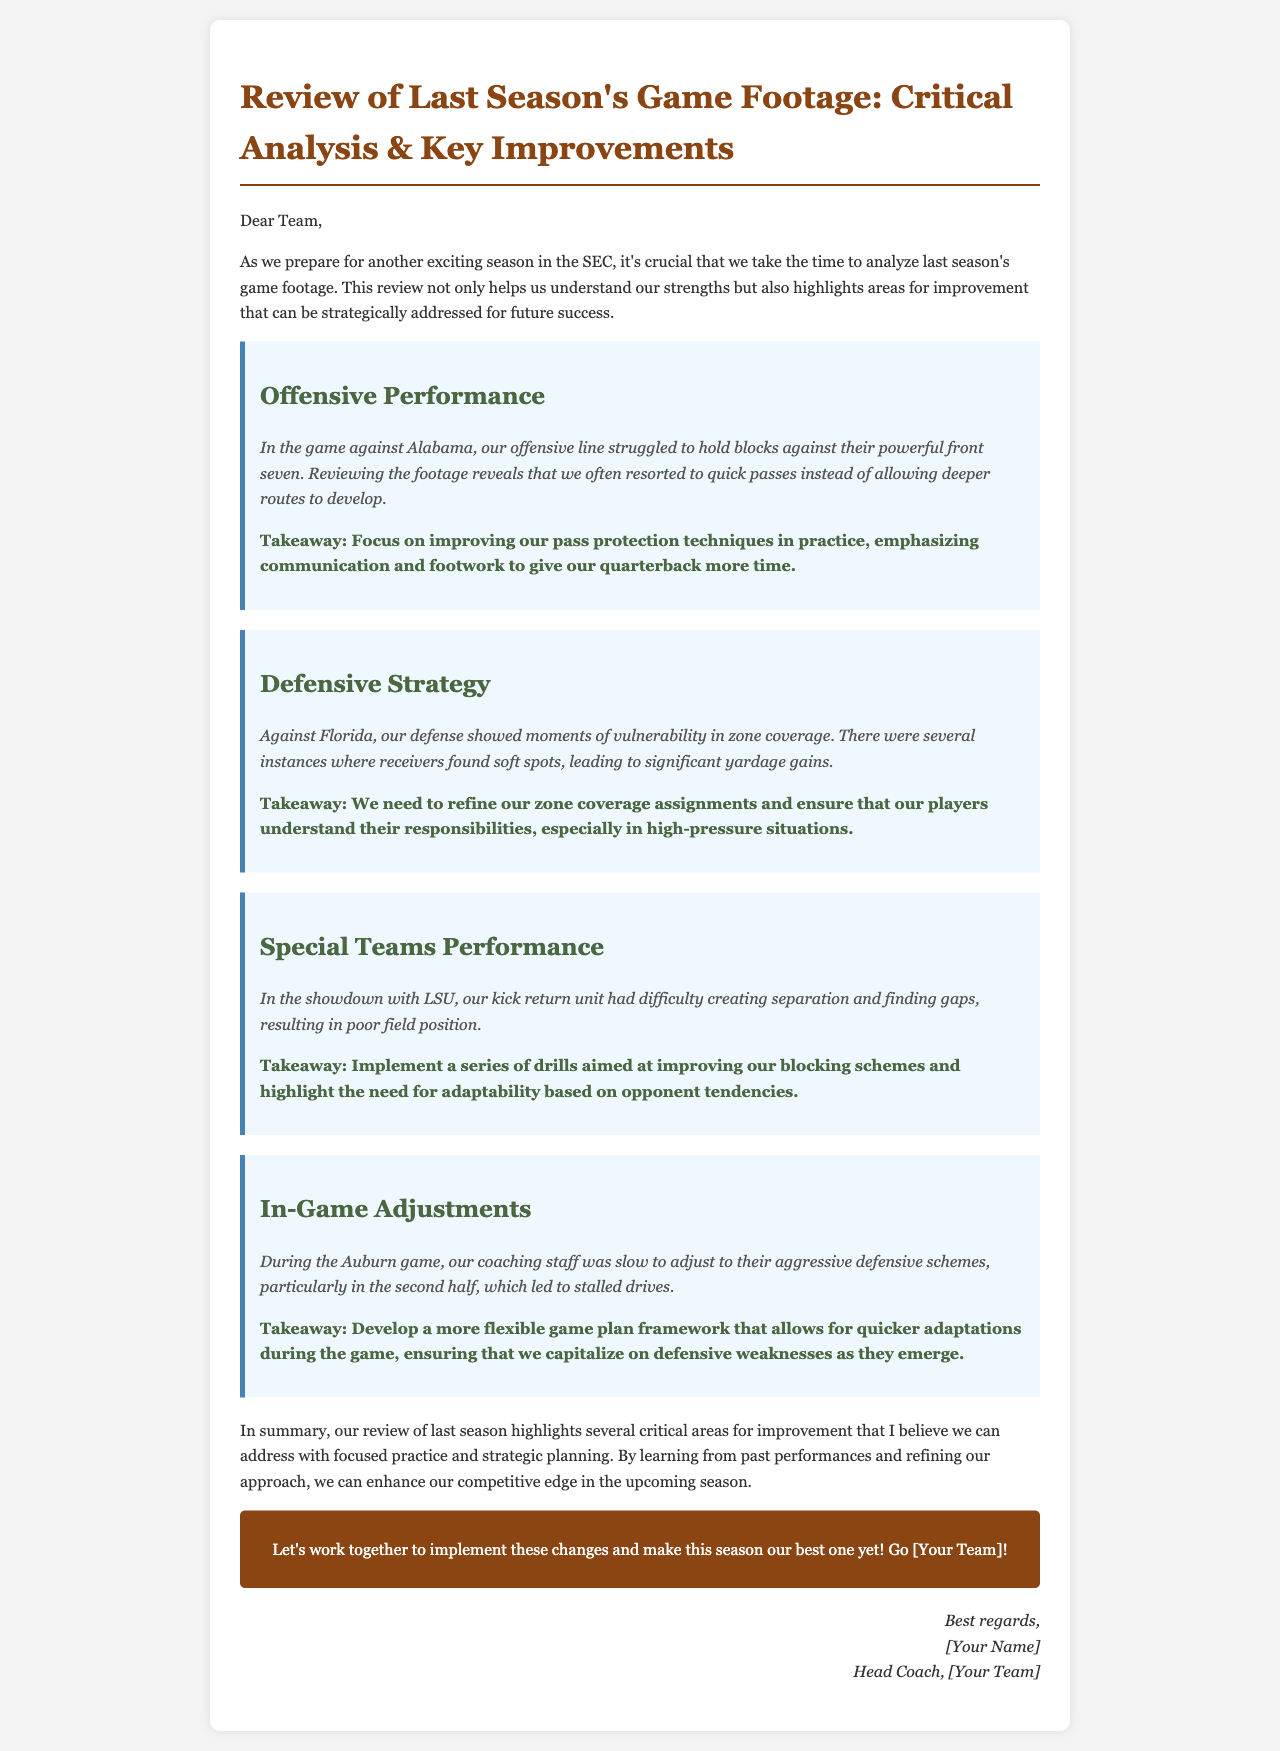What was identified as an issue in the offensive performance? The document highlights that the offensive line struggled to hold blocks against Alabama, leading to quick passes instead of deeper routes.
Answer: Offensive line struggled to hold blocks What is the key takeaway for improving pass protection? The document suggests improving pass protection techniques in practice, focusing on communication and footwork for better quarterback support.
Answer: Improve pass protection techniques What defensive issue was noted against Florida? The analysis pointed out vulnerabilities in zone coverage, leading to significant yardage gains for receivers.
Answer: Vulnerabilities in zone coverage What adjustment was required for special teams performance? The document emphasizes the need for improved blocking schemes and adaptability based on opponent tendencies for the kick return unit.
Answer: Improved blocking schemes What is suggested for in-game adjustments during games? It is recommended to develop a more flexible game plan framework for quicker adaptations to capitalize on defensive weaknesses.
Answer: Flexible game plan framework How many key performance areas are highlighted for improvement? The document lists four critical areas for improvement based on game footage review.
Answer: Four What season does this review pertain to? The email explicitly states that it is a review of last season's game footage, indicating the previous competitive season.
Answer: Last season What is the closing sentiment expressed by the coach? The coach encourages team collaboration for the upcoming season, aiming for their best performance yet.
Answer: Make this season our best one yet 